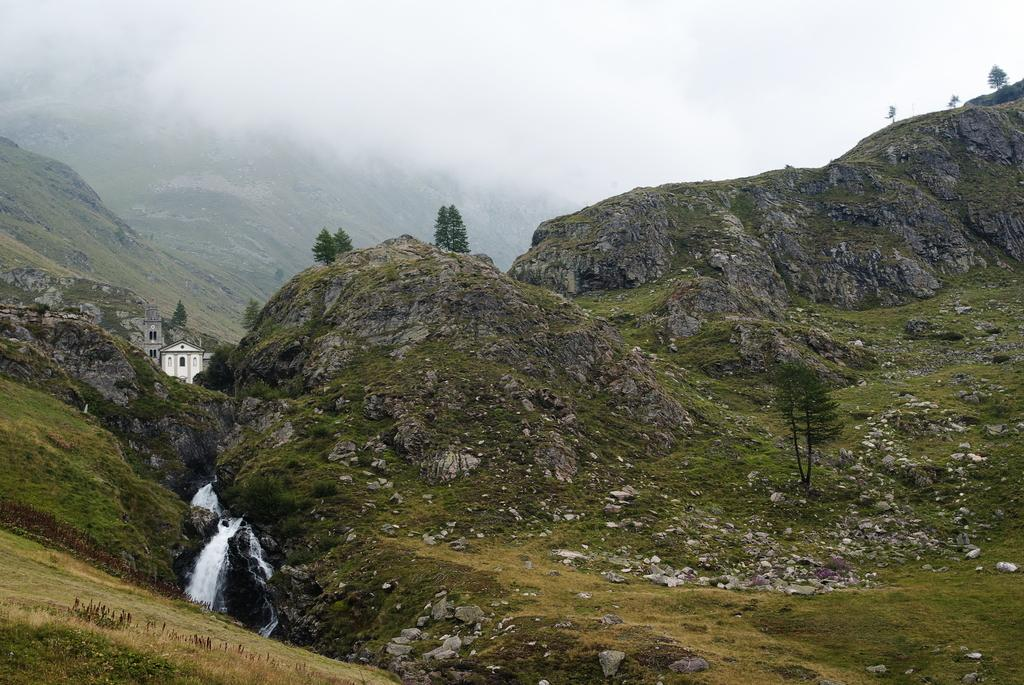What type of vegetation is present in the image? There is grass in the image. What type of structures can be seen in the image? There are houses in the image. What other natural elements are visible in the image? There are trees and rocks in the image. What is the condition of the background in the image? The background of the image includes fog. What is visible in the sky in the image? The sky is visible in the background of the image. How many flocks of birds can be seen flying over the houses in the image? There are no flocks of birds visible in the image. What type of stretch exercise is being performed by the trees in the image? The trees in the image are not performing any stretch exercises; they are stationary natural elements. 